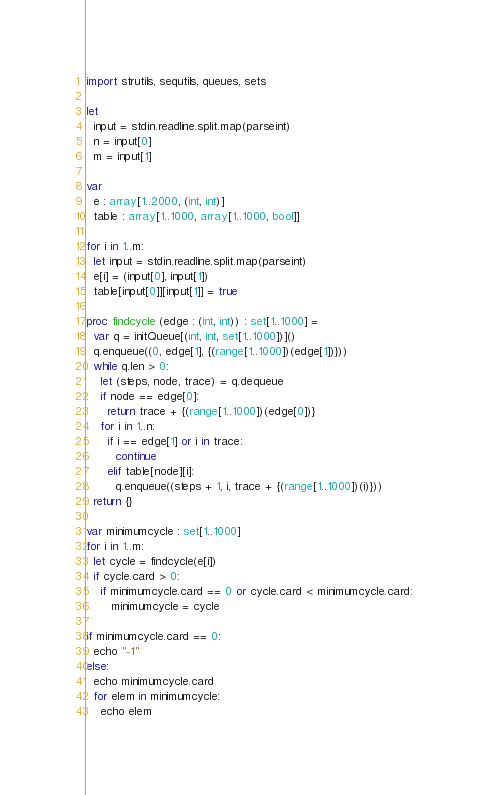<code> <loc_0><loc_0><loc_500><loc_500><_Nim_>import strutils, sequtils, queues, sets

let
  input = stdin.readline.split.map(parseint)
  n = input[0]
  m = input[1]

var
  e : array[1..2000, (int, int)]
  table : array[1..1000, array[1..1000, bool]]

for i in 1..m:
  let input = stdin.readline.split.map(parseint)
  e[i] = (input[0], input[1])
  table[input[0]][input[1]] = true

proc findcycle (edge : (int, int)) : set[1..1000] =
  var q = initQueue[(int, int, set[1..1000])]()
  q.enqueue((0, edge[1], {(range[1..1000])(edge[1])}))
  while q.len > 0:
    let (steps, node, trace) = q.dequeue
    if node == edge[0]:
      return trace + {(range[1..1000])(edge[0])}
    for i in 1..n:
      if i == edge[1] or i in trace:
        continue
      elif table[node][i]:
        q.enqueue((steps + 1, i, trace + {(range[1..1000])(i)}))
  return {}

var minimumcycle : set[1..1000]
for i in 1..m:
  let cycle = findcycle(e[i])
  if cycle.card > 0:
    if minimumcycle.card == 0 or cycle.card < minimumcycle.card:
       minimumcycle = cycle

if minimumcycle.card == 0:
  echo "-1"
else:
  echo minimumcycle.card
  for elem in minimumcycle:
    echo elem
</code> 